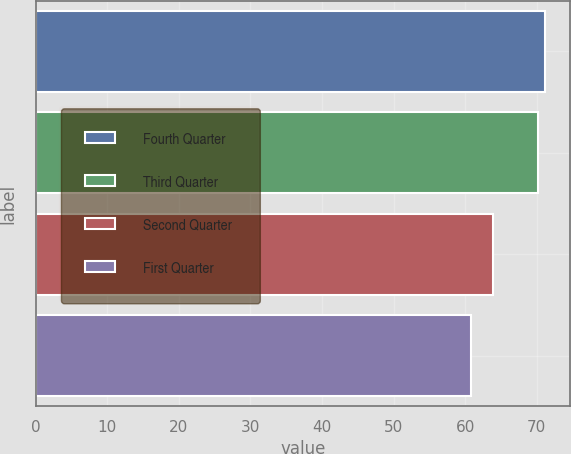<chart> <loc_0><loc_0><loc_500><loc_500><bar_chart><fcel>Fourth Quarter<fcel>Third Quarter<fcel>Second Quarter<fcel>First Quarter<nl><fcel>71.12<fcel>70.18<fcel>63.85<fcel>60.84<nl></chart> 